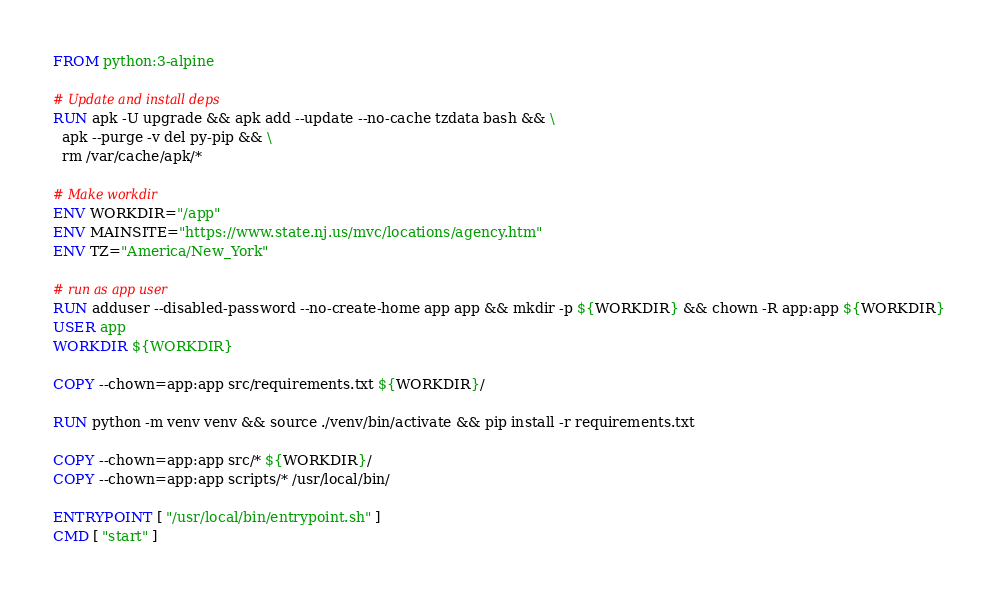Convert code to text. <code><loc_0><loc_0><loc_500><loc_500><_Dockerfile_>FROM python:3-alpine

# Update and install deps
RUN apk -U upgrade && apk add --update --no-cache tzdata bash && \
  apk --purge -v del py-pip && \
  rm /var/cache/apk/*

# Make workdir
ENV WORKDIR="/app"
ENV MAINSITE="https://www.state.nj.us/mvc/locations/agency.htm"
ENV TZ="America/New_York"

# run as app user
RUN adduser --disabled-password --no-create-home app app && mkdir -p ${WORKDIR} && chown -R app:app ${WORKDIR}
USER app
WORKDIR ${WORKDIR}

COPY --chown=app:app src/requirements.txt ${WORKDIR}/

RUN python -m venv venv && source ./venv/bin/activate && pip install -r requirements.txt

COPY --chown=app:app src/* ${WORKDIR}/
COPY --chown=app:app scripts/* /usr/local/bin/

ENTRYPOINT [ "/usr/local/bin/entrypoint.sh" ]
CMD [ "start" ]</code> 